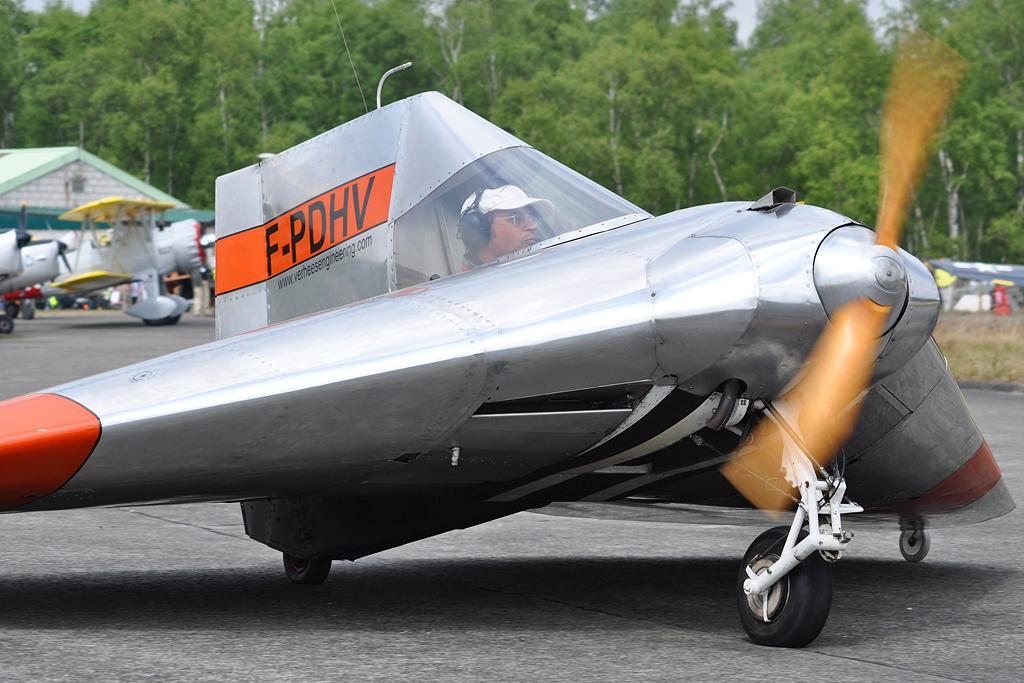<image>
Create a compact narrative representing the image presented. A plane that is mostly silver with orange wings and orange on the fin with the letters F-PDHV. 